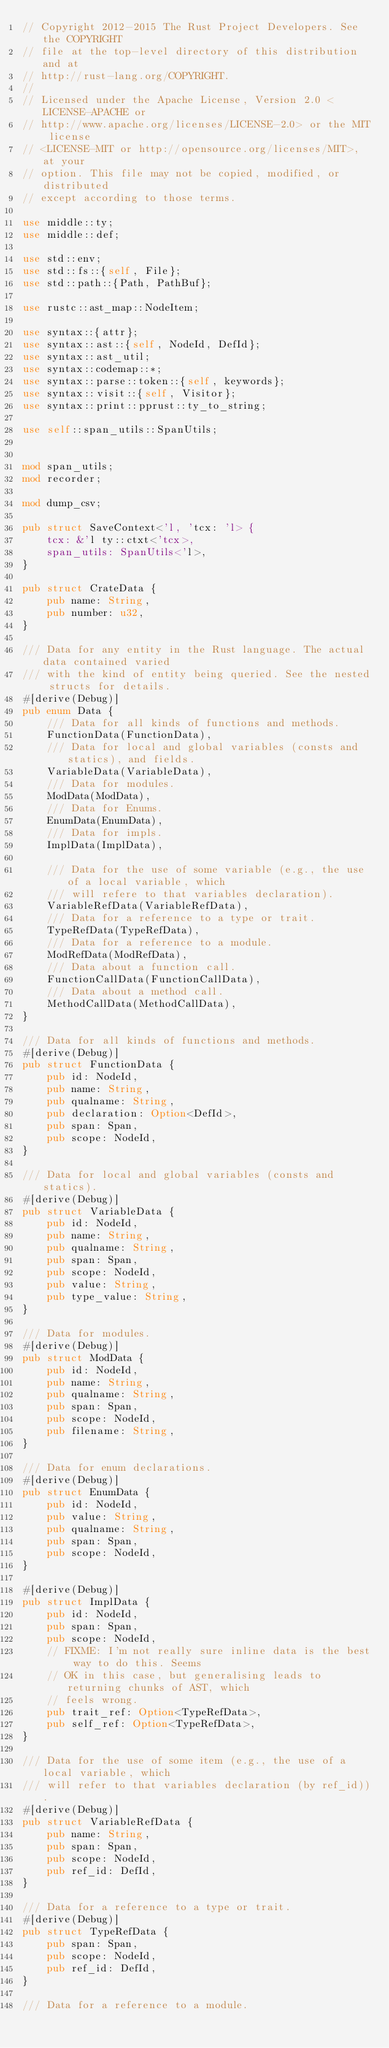Convert code to text. <code><loc_0><loc_0><loc_500><loc_500><_Rust_>// Copyright 2012-2015 The Rust Project Developers. See the COPYRIGHT
// file at the top-level directory of this distribution and at
// http://rust-lang.org/COPYRIGHT.
//
// Licensed under the Apache License, Version 2.0 <LICENSE-APACHE or
// http://www.apache.org/licenses/LICENSE-2.0> or the MIT license
// <LICENSE-MIT or http://opensource.org/licenses/MIT>, at your
// option. This file may not be copied, modified, or distributed
// except according to those terms.

use middle::ty;
use middle::def;

use std::env;
use std::fs::{self, File};
use std::path::{Path, PathBuf};

use rustc::ast_map::NodeItem;

use syntax::{attr};
use syntax::ast::{self, NodeId, DefId};
use syntax::ast_util;
use syntax::codemap::*;
use syntax::parse::token::{self, keywords};
use syntax::visit::{self, Visitor};
use syntax::print::pprust::ty_to_string;

use self::span_utils::SpanUtils;


mod span_utils;
mod recorder;

mod dump_csv;

pub struct SaveContext<'l, 'tcx: 'l> {
    tcx: &'l ty::ctxt<'tcx>,
    span_utils: SpanUtils<'l>,
}

pub struct CrateData {
    pub name: String,
    pub number: u32,
}

/// Data for any entity in the Rust language. The actual data contained varied
/// with the kind of entity being queried. See the nested structs for details.
#[derive(Debug)]
pub enum Data {
    /// Data for all kinds of functions and methods.
    FunctionData(FunctionData),
    /// Data for local and global variables (consts and statics), and fields.
    VariableData(VariableData),
    /// Data for modules.
    ModData(ModData),
    /// Data for Enums.
    EnumData(EnumData),
    /// Data for impls.
    ImplData(ImplData),

    /// Data for the use of some variable (e.g., the use of a local variable, which
    /// will refere to that variables declaration).
    VariableRefData(VariableRefData),
    /// Data for a reference to a type or trait.
    TypeRefData(TypeRefData),
    /// Data for a reference to a module.
    ModRefData(ModRefData),
    /// Data about a function call.
    FunctionCallData(FunctionCallData),
    /// Data about a method call.
    MethodCallData(MethodCallData),
}

/// Data for all kinds of functions and methods.
#[derive(Debug)]
pub struct FunctionData {
    pub id: NodeId,
    pub name: String,
    pub qualname: String,
    pub declaration: Option<DefId>,
    pub span: Span,
    pub scope: NodeId,
}

/// Data for local and global variables (consts and statics).
#[derive(Debug)]
pub struct VariableData {
    pub id: NodeId,
    pub name: String,
    pub qualname: String,
    pub span: Span,
    pub scope: NodeId,
    pub value: String,
    pub type_value: String,
}

/// Data for modules.
#[derive(Debug)]
pub struct ModData {
    pub id: NodeId,
    pub name: String,
    pub qualname: String,
    pub span: Span,
    pub scope: NodeId,
    pub filename: String,
}

/// Data for enum declarations.
#[derive(Debug)]
pub struct EnumData {
    pub id: NodeId,
    pub value: String,
    pub qualname: String,
    pub span: Span,
    pub scope: NodeId,
}

#[derive(Debug)]
pub struct ImplData {
    pub id: NodeId,
    pub span: Span,
    pub scope: NodeId,
    // FIXME: I'm not really sure inline data is the best way to do this. Seems
    // OK in this case, but generalising leads to returning chunks of AST, which
    // feels wrong.
    pub trait_ref: Option<TypeRefData>,
    pub self_ref: Option<TypeRefData>,
}

/// Data for the use of some item (e.g., the use of a local variable, which
/// will refer to that variables declaration (by ref_id)).
#[derive(Debug)]
pub struct VariableRefData {
    pub name: String,
    pub span: Span,
    pub scope: NodeId,
    pub ref_id: DefId,
}

/// Data for a reference to a type or trait.
#[derive(Debug)]
pub struct TypeRefData {
    pub span: Span,
    pub scope: NodeId,
    pub ref_id: DefId,
}

/// Data for a reference to a module.</code> 